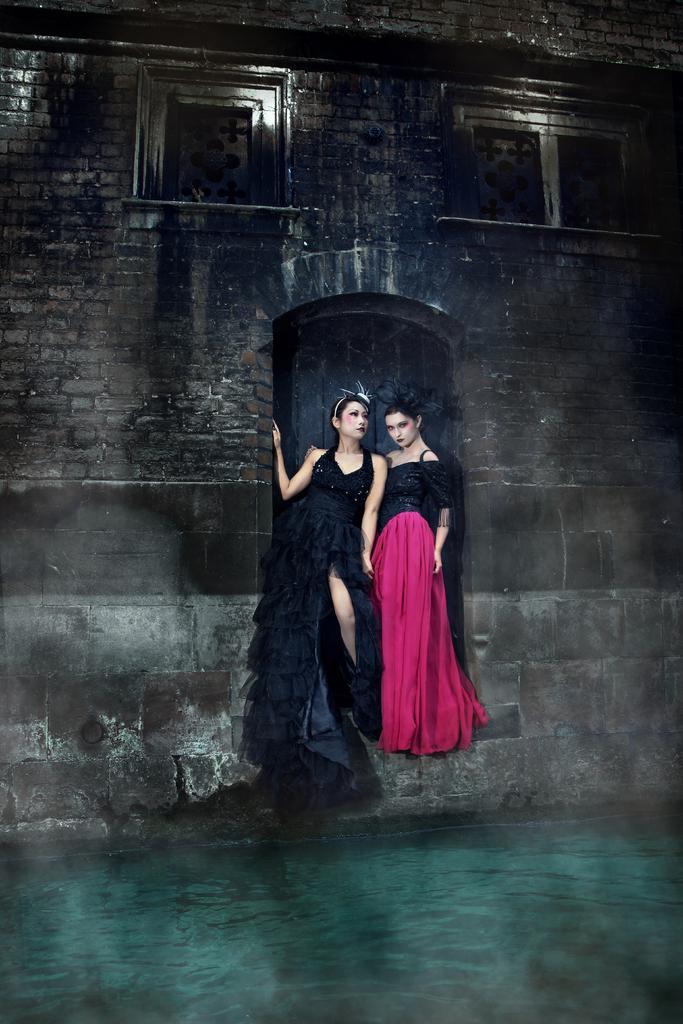Describe this image in one or two sentences. At the bottom of the image there is water. In the middle of the image two women are standing. Behind them there is wall. 